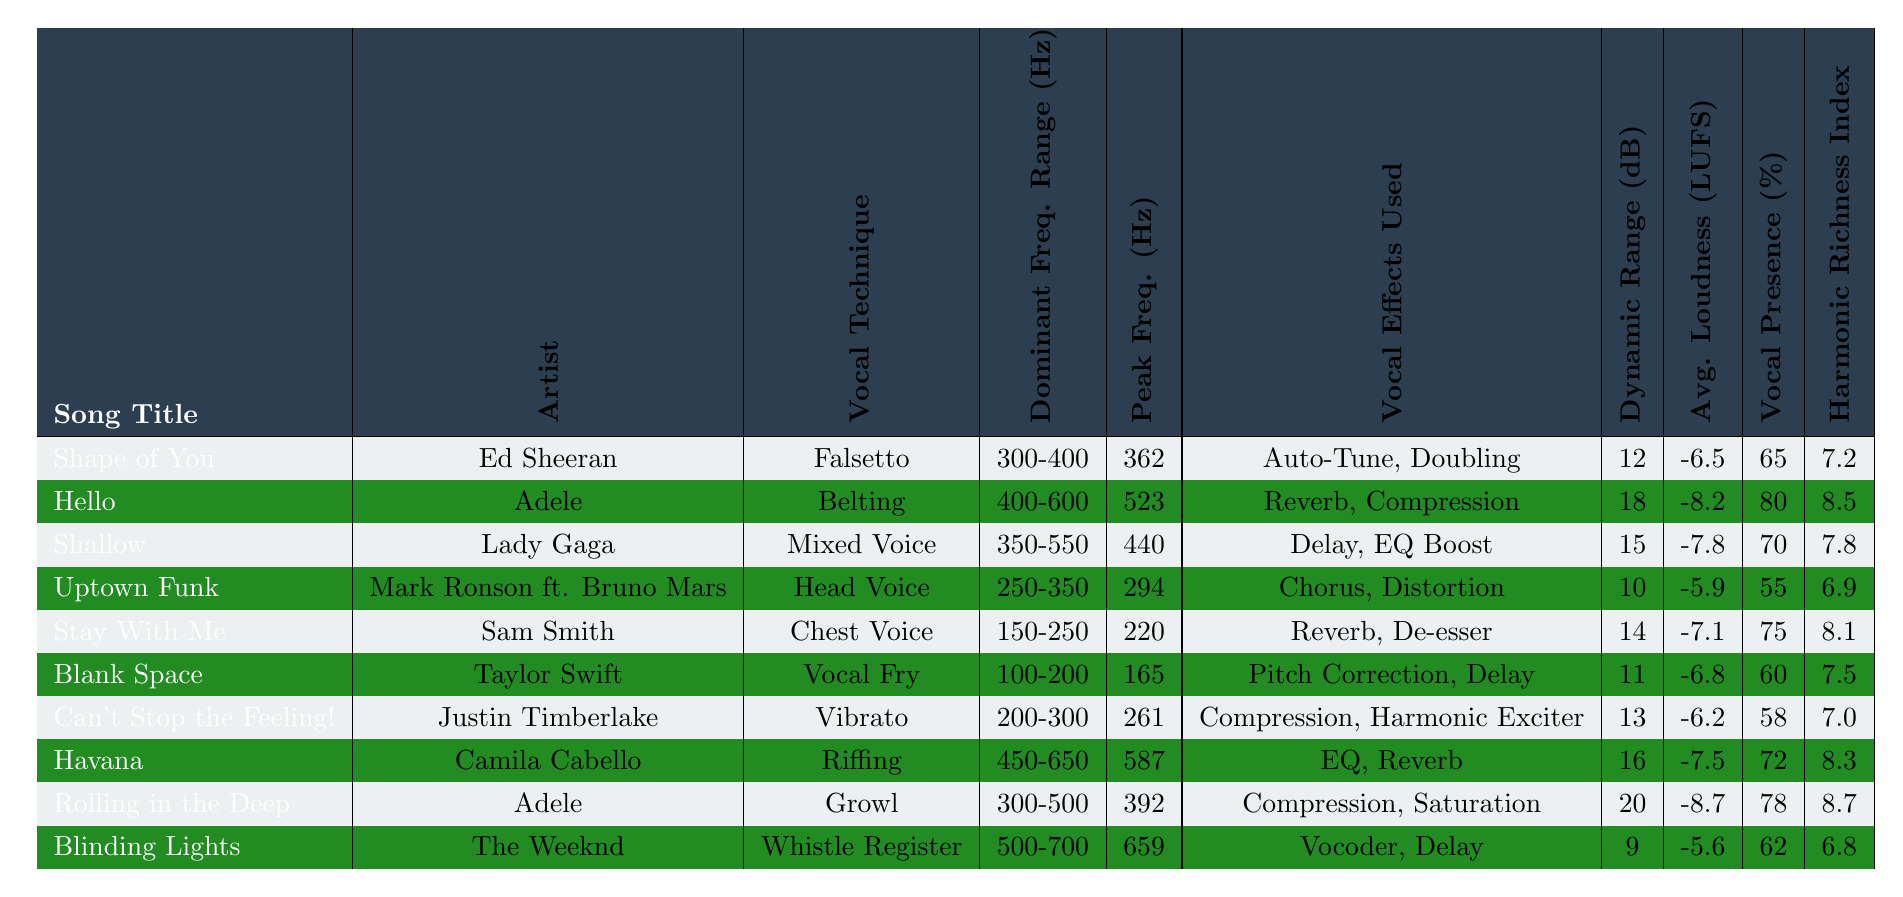What vocal technique is used in "Rolling in the Deep"? By looking at the row for "Rolling in the Deep," the vocal technique listed is "Growl."
Answer: Growl Which song has the highest dynamic range? Checking the dynamic range values, "Rolling in the Deep" has a dynamic range of 20 dB, which is the highest in the table.
Answer: 20 dB What is the peak frequency used in "Shallow"? The peak frequency for "Shallow" is found in its respective row, listed as 440 Hz.
Answer: 440 Hz Do any songs use "Reverb" as a vocal effect? By scanning the "Vocal Effects Used" column, both "Hello" and "Stay With Me" include "Reverb" in their effects.
Answer: Yes What is the average loudness of the songs using "Vibrato"? The only song using "Vibrato" is "Can't Stop the Feeling!" with an average loudness of -6.2 LUFS. As there is one value, the average is -6.2 LUFS.
Answer: -6.2 LUFS Which vocal technique corresponds to the song "Blank Space"? The technique for "Blank Space" can be located by checking its row, which indicates "Vocal Fry."
Answer: Vocal Fry Is there a song with a vocal presence percentage higher than 75%? Looking through the "Vocal Presence (%)" column, both "Hello" and "Rolling in the Deep" exceed 75%, confirming the fact.
Answer: Yes Which song features "Auto-Tune" but not "Compression" as a vocal effect? Evaluating the "Vocal Effects Used" column, only "Shape of You" features "Auto-Tune" without listing "Compression."
Answer: Shape of You What is the harmonic richness index of the song with the highest peak frequency? "Blinding Lights" has the highest peak frequency of 659 Hz, and its harmonic richness index is 6.8.
Answer: 6.8 